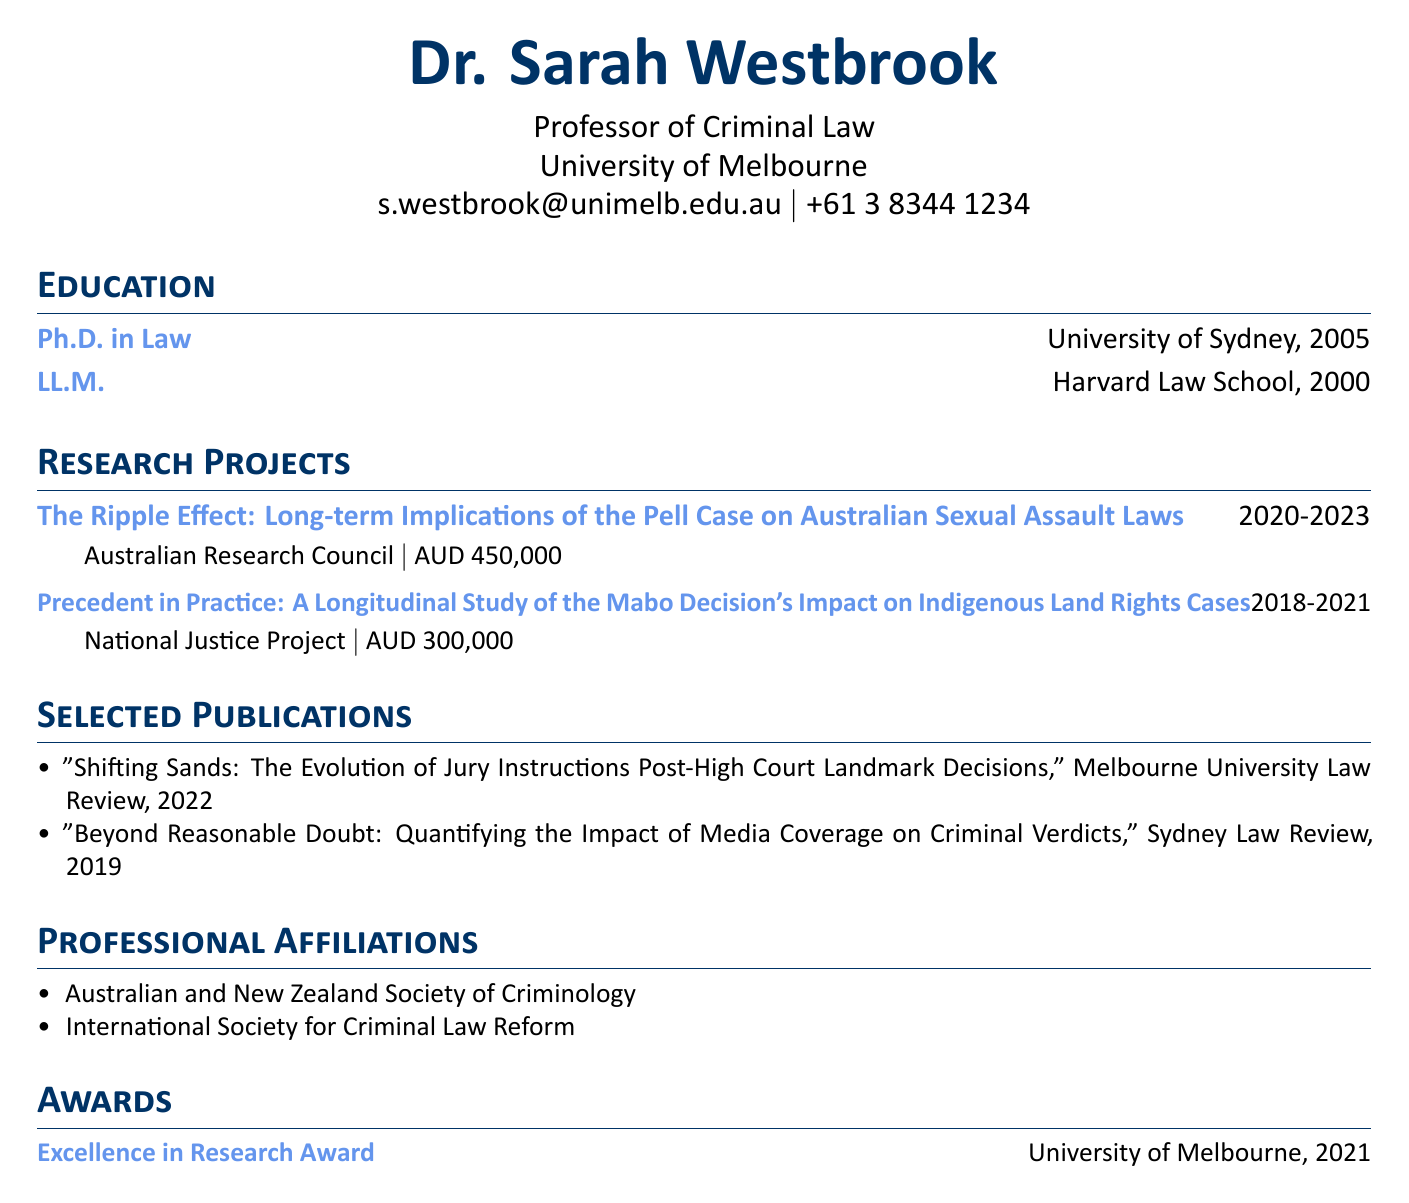what is the name of the professor? The document states the professor's name as Dr. Sarah Westbrook.
Answer: Dr. Sarah Westbrook which institution does Dr. Sarah Westbrook work for? The document lists Dr. Sarah Westbrook's institution as the University of Melbourne.
Answer: University of Melbourne how much funding was received for the Pell case research project? The document details that the grant amount for the Pell case research project is AUD 450,000.
Answer: AUD 450,000 what year did the Mabo Decision's impact study start? The projects section indicates that the Mabo Decision's impact study started in 2018.
Answer: 2018 which award did Dr. Sarah Westbrook receive in 2021? The document mentions that she received the Excellence in Research Award from the University of Melbourne.
Answer: Excellence in Research Award how many professional affiliations are listed? Counting the affiliations, there are two listed: Australian and New Zealand Society of Criminology and International Society for Criminal Law Reform.
Answer: 2 what is the duration of the project titled "The Ripple Effect"? The document specifies that the duration of the project titled "The Ripple Effect" is from 2020 to 2023.
Answer: 2020-2023 in which journal was the publication about jury instructions released? The document shows that the publication on jury instructions was released in the Melbourne University Law Review.
Answer: Melbourne University Law Review what degree did Dr. Sarah Westbrook earn in 2000? The education section recounts that she earned an LL.M. in 2000.
Answer: LL.M 